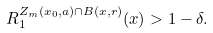Convert formula to latex. <formula><loc_0><loc_0><loc_500><loc_500>R _ { 1 } ^ { Z _ { m } ( x _ { 0 } , a ) \cap B ( x , r ) } ( x ) > 1 - \delta .</formula> 